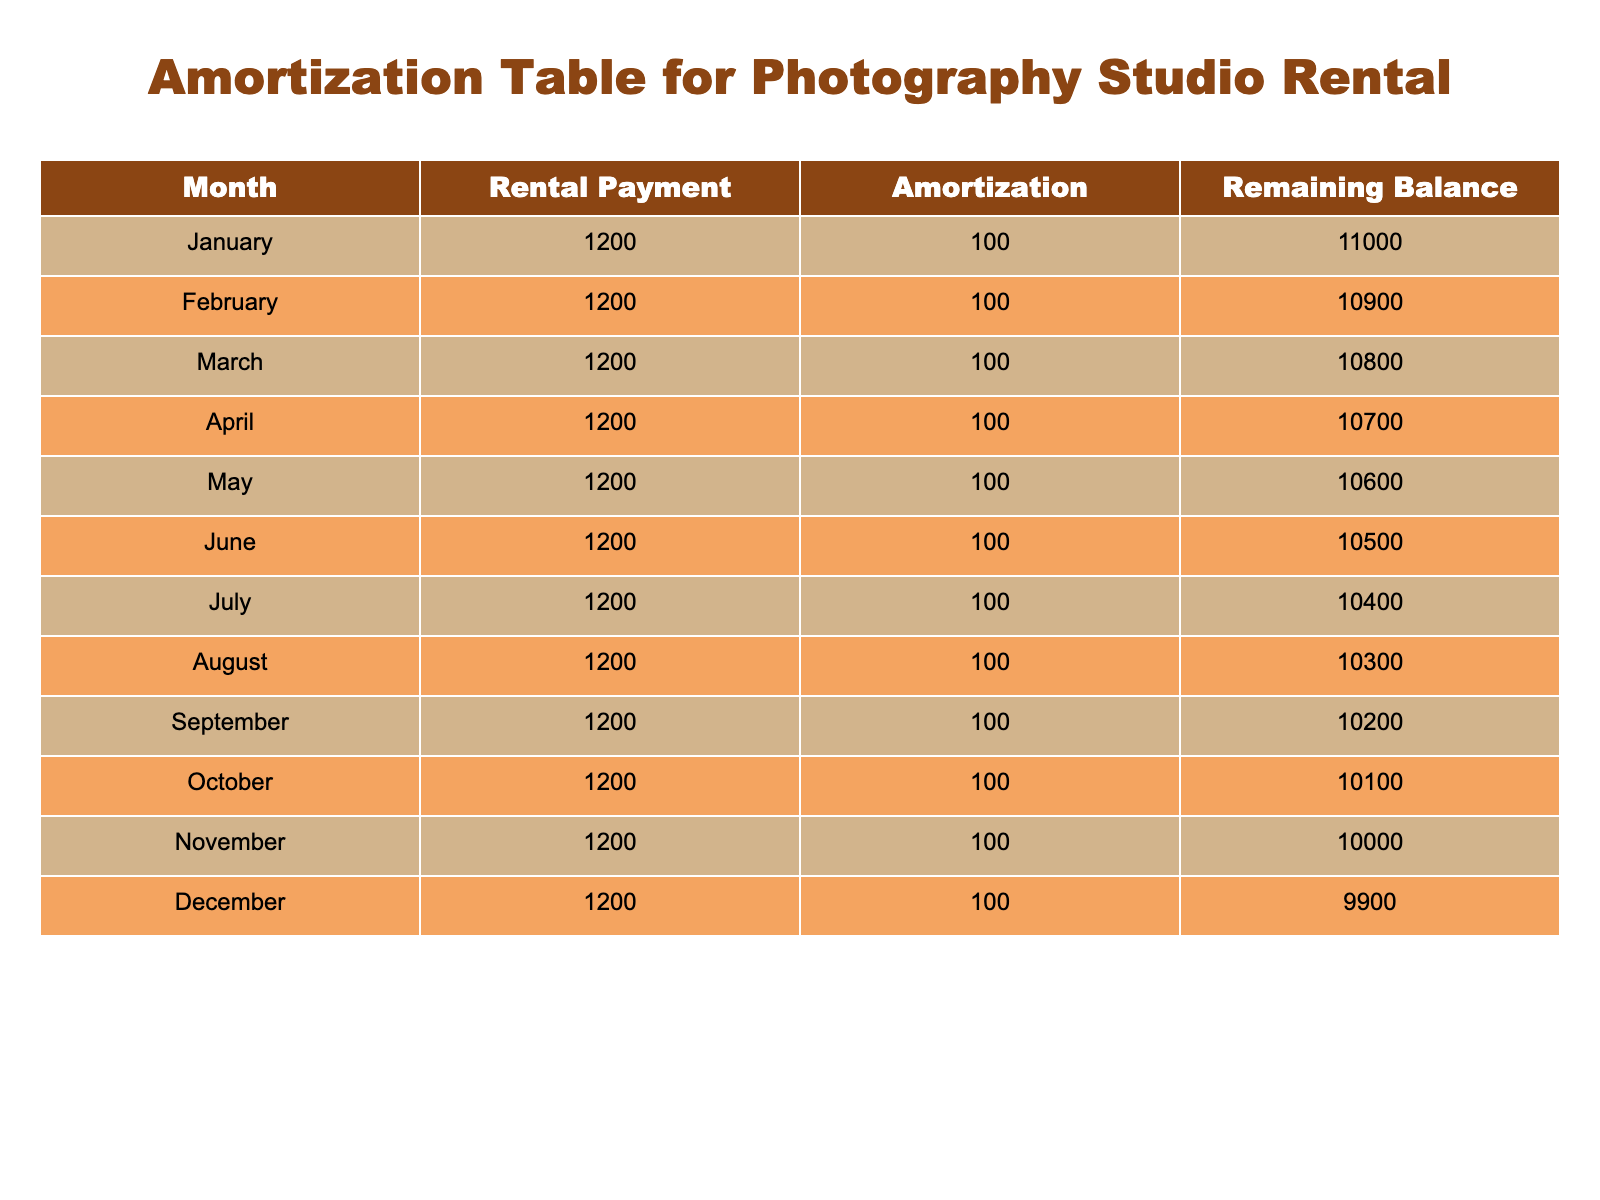What is the rental payment for each month? The table shows a consistent rental payment of 1200 for each month from January to December.
Answer: 1200 What is the remaining balance at the end of June? Referring to the table, the remaining balance listed for June is 10500.
Answer: 10500 How much total amortization occurs in one year? The amortization amount is consistent at 100 per month, so for 12 months, the total amortization is 100 x 12 = 1200.
Answer: 1200 Is the rental payment the same for every month? Yes, the table indicates that the rental payment remains constant at 1200 for all months throughout the year.
Answer: Yes What is the remaining balance after the November payment? According to the table, the remaining balance after the January to November payments is 10000.
Answer: 10000 What is the average amortization per month over the year? The table shows a constant amortization value of 100 each month, making the average also 100 since there are no variations.
Answer: 100 If I wanted to know the difference in remaining balance between the start and end of the year, what would it be? The starting balance in January is 11000 and the ending balance in December is 9900. Therefore, the difference is 11000 - 9900 = 1100.
Answer: 1100 In which month is the remaining balance the lowest? The table shows the remaining balance decreasing sequentially, with the lowest balance of 9900 recorded in December.
Answer: December What is the trend of the remaining balance month over month? The remaining balance consistently decreases by 100 each month from January (11000) to December (9900), indicating a steady downward trend.
Answer: Decreasing by 100 each month 